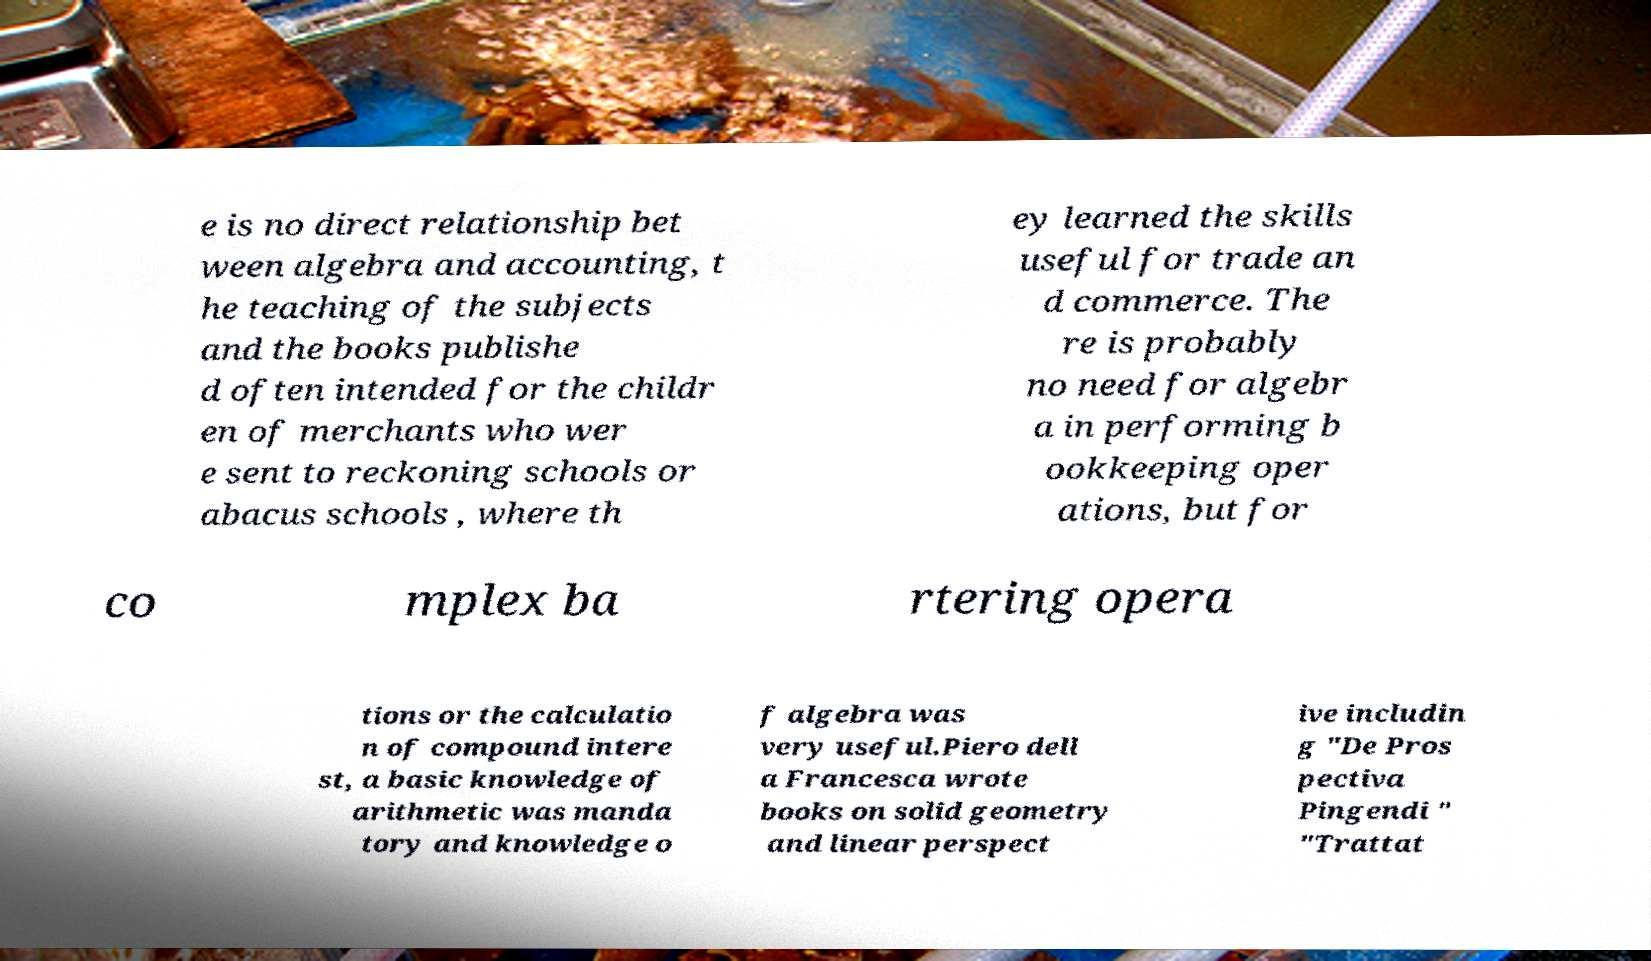I need the written content from this picture converted into text. Can you do that? e is no direct relationship bet ween algebra and accounting, t he teaching of the subjects and the books publishe d often intended for the childr en of merchants who wer e sent to reckoning schools or abacus schools , where th ey learned the skills useful for trade an d commerce. The re is probably no need for algebr a in performing b ookkeeping oper ations, but for co mplex ba rtering opera tions or the calculatio n of compound intere st, a basic knowledge of arithmetic was manda tory and knowledge o f algebra was very useful.Piero dell a Francesca wrote books on solid geometry and linear perspect ive includin g "De Pros pectiva Pingendi " "Trattat 